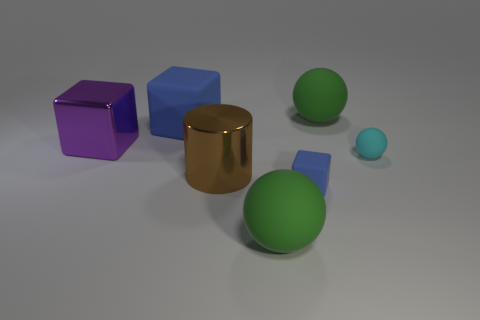How many other things are there of the same size as the brown shiny cylinder?
Provide a succinct answer. 4. What size is the purple object that is the same shape as the tiny blue rubber thing?
Your answer should be compact. Large. The brown metallic object to the right of the big purple shiny thing has what shape?
Provide a short and direct response. Cylinder. What color is the shiny thing that is to the left of the blue block behind the purple shiny block?
Provide a succinct answer. Purple. What number of objects are either green matte balls behind the big rubber block or tiny cyan matte cylinders?
Keep it short and to the point. 1. There is a cyan thing; is it the same size as the matte cube that is behind the brown shiny thing?
Keep it short and to the point. No. What number of big objects are shiny cylinders or metallic objects?
Keep it short and to the point. 2. What shape is the large blue rubber thing?
Ensure brevity in your answer.  Cube. There is another cube that is the same color as the big rubber cube; what size is it?
Ensure brevity in your answer.  Small. Is there a small purple thing that has the same material as the large blue object?
Offer a very short reply. No. 